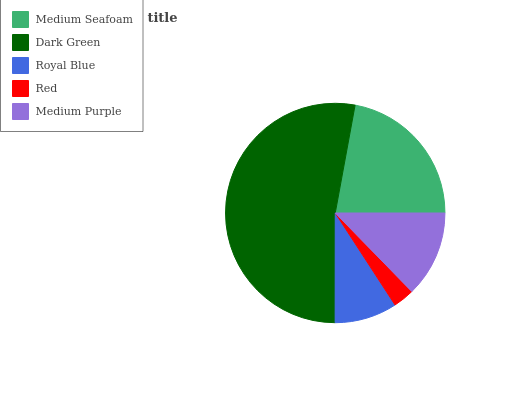Is Red the minimum?
Answer yes or no. Yes. Is Dark Green the maximum?
Answer yes or no. Yes. Is Royal Blue the minimum?
Answer yes or no. No. Is Royal Blue the maximum?
Answer yes or no. No. Is Dark Green greater than Royal Blue?
Answer yes or no. Yes. Is Royal Blue less than Dark Green?
Answer yes or no. Yes. Is Royal Blue greater than Dark Green?
Answer yes or no. No. Is Dark Green less than Royal Blue?
Answer yes or no. No. Is Medium Purple the high median?
Answer yes or no. Yes. Is Medium Purple the low median?
Answer yes or no. Yes. Is Red the high median?
Answer yes or no. No. Is Royal Blue the low median?
Answer yes or no. No. 